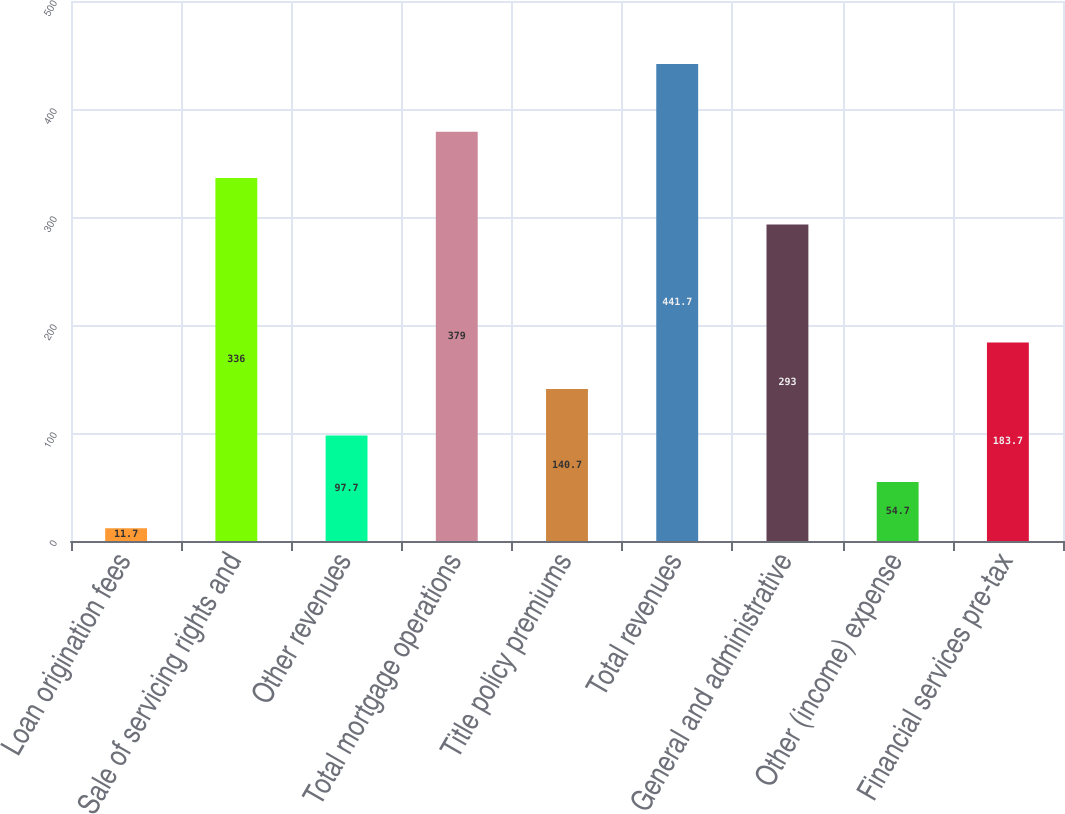Convert chart. <chart><loc_0><loc_0><loc_500><loc_500><bar_chart><fcel>Loan origination fees<fcel>Sale of servicing rights and<fcel>Other revenues<fcel>Total mortgage operations<fcel>Title policy premiums<fcel>Total revenues<fcel>General and administrative<fcel>Other (income) expense<fcel>Financial services pre-tax<nl><fcel>11.7<fcel>336<fcel>97.7<fcel>379<fcel>140.7<fcel>441.7<fcel>293<fcel>54.7<fcel>183.7<nl></chart> 